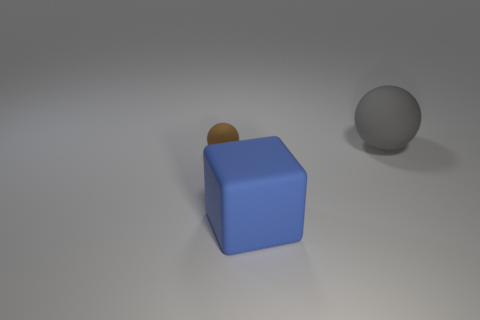Subtract all spheres. How many objects are left? 1 Add 1 tiny metal spheres. How many objects exist? 4 Subtract all green blocks. How many brown spheres are left? 1 Subtract 0 cyan blocks. How many objects are left? 3 Subtract all gray blocks. Subtract all red cylinders. How many blocks are left? 1 Subtract all blue matte objects. Subtract all brown spheres. How many objects are left? 1 Add 3 small brown rubber objects. How many small brown rubber objects are left? 4 Add 2 small green metal balls. How many small green metal balls exist? 2 